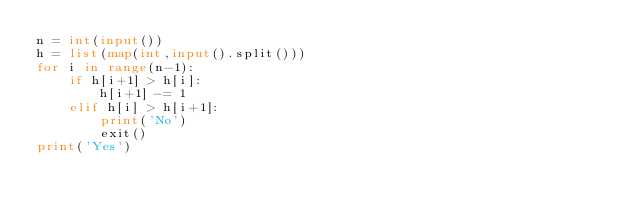<code> <loc_0><loc_0><loc_500><loc_500><_Python_>n = int(input())
h = list(map(int,input().split()))
for i in range(n-1):
    if h[i+1] > h[i]:
        h[i+1] -= 1
    elif h[i] > h[i+1]:
        print('No')
        exit()
print('Yes')</code> 